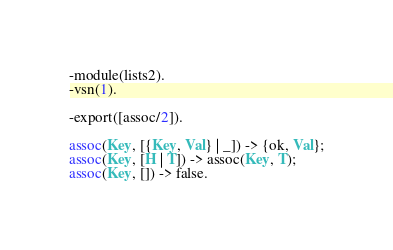Convert code to text. <code><loc_0><loc_0><loc_500><loc_500><_Erlang_>-module(lists2).
-vsn(1).

-export([assoc/2]).

assoc(Key, [{Key, Val} | _]) -> {ok, Val};
assoc(Key, [H | T]) -> assoc(Key, T);
assoc(Key, []) -> false.
</code> 